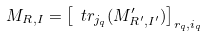<formula> <loc_0><loc_0><loc_500><loc_500>M _ { R , I } = \left [ \ t r _ { j _ { q } } ( M ^ { \prime } _ { R ^ { \prime } , I ^ { \prime } } ) \right ] _ { r _ { q } , i _ { q } }</formula> 